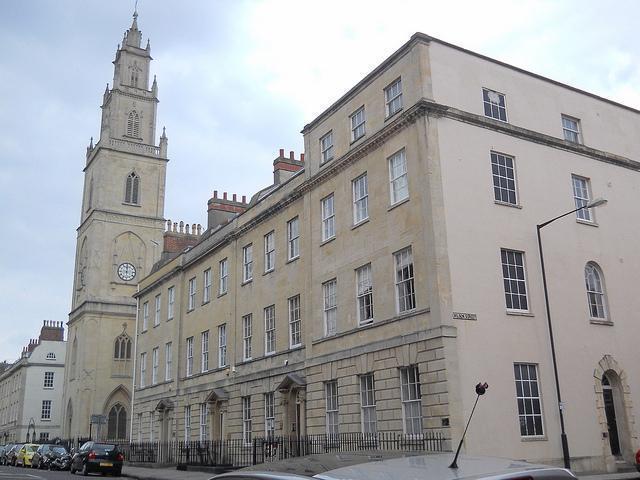What color are the chimney pieces on the top of the long rectangular house?
Pick the right solution, then justify: 'Answer: answer
Rationale: rationale.'
Options: Blue, green, red, yellow. Answer: red.
Rationale: The color is easily visible and bright.  it is in sharp contrast to the brown building. 